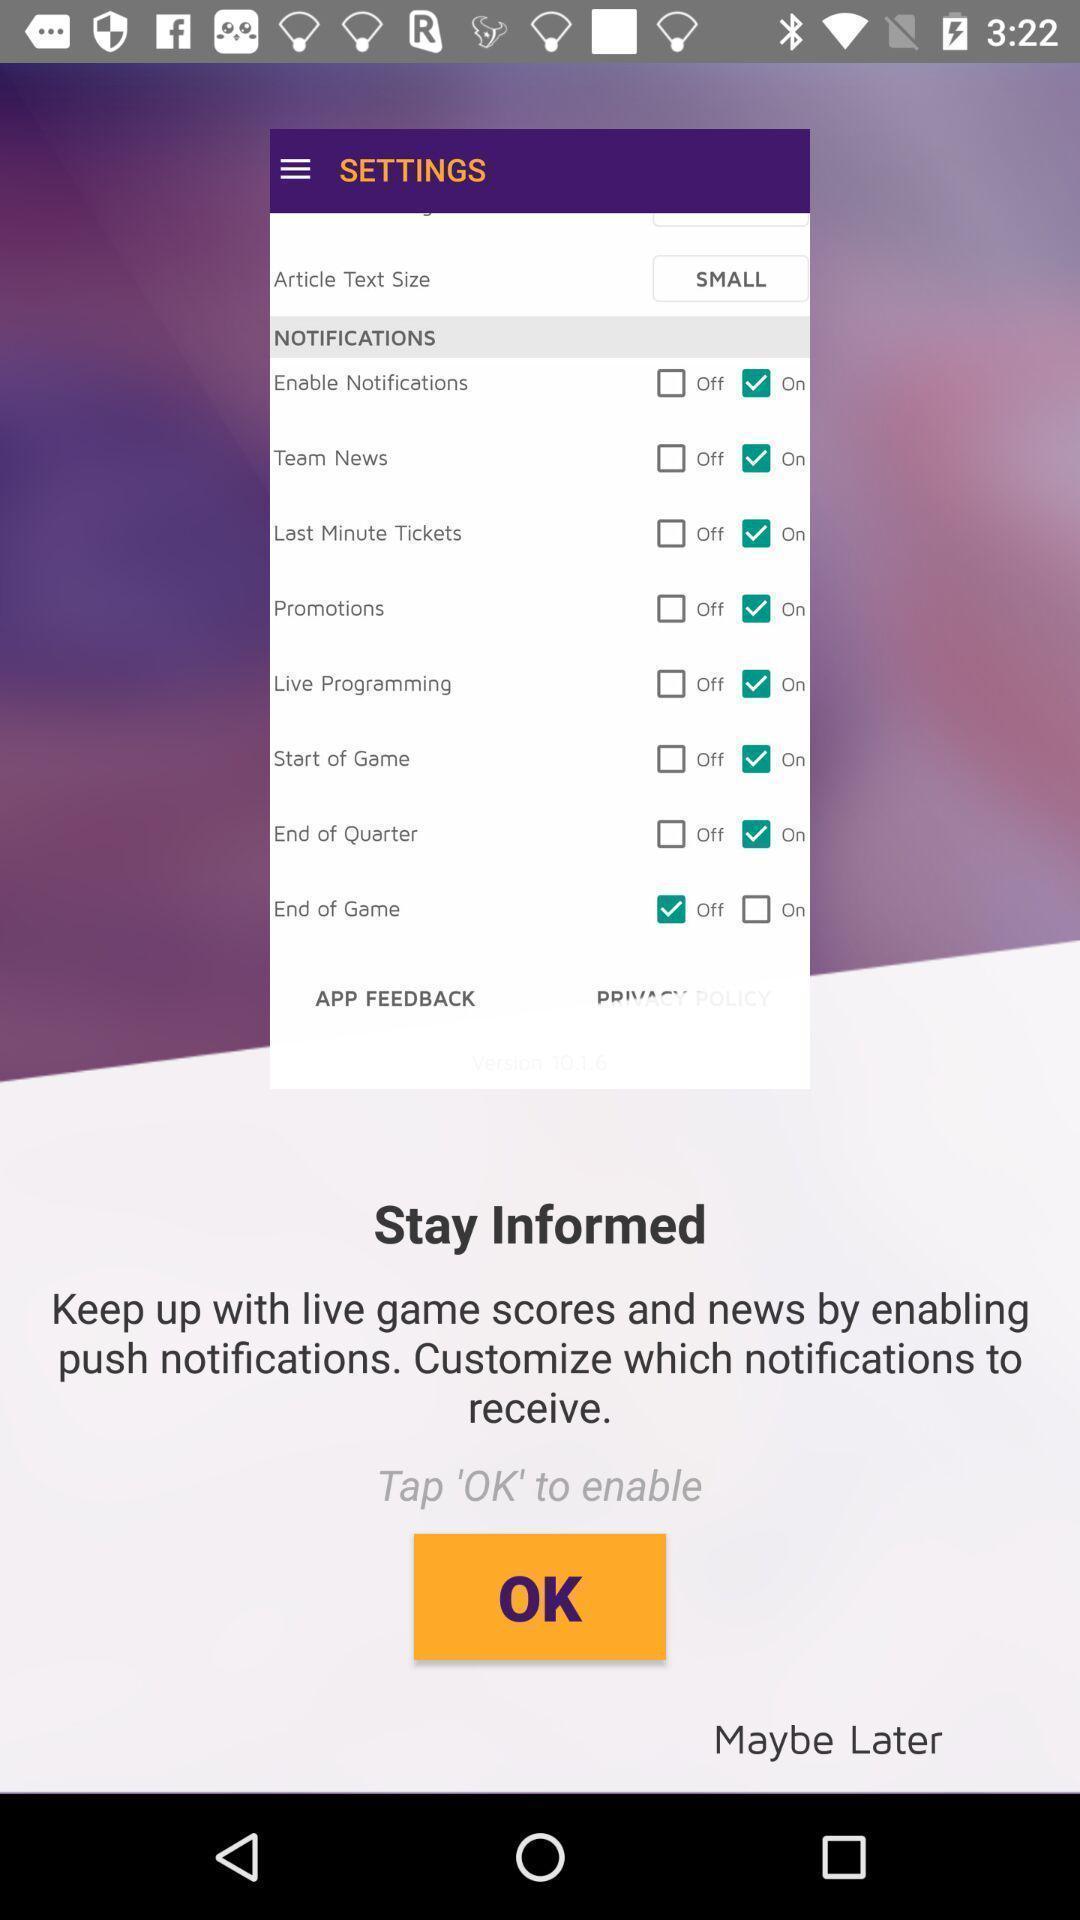What is the overall content of this screenshot? Welcome page of the official app. 